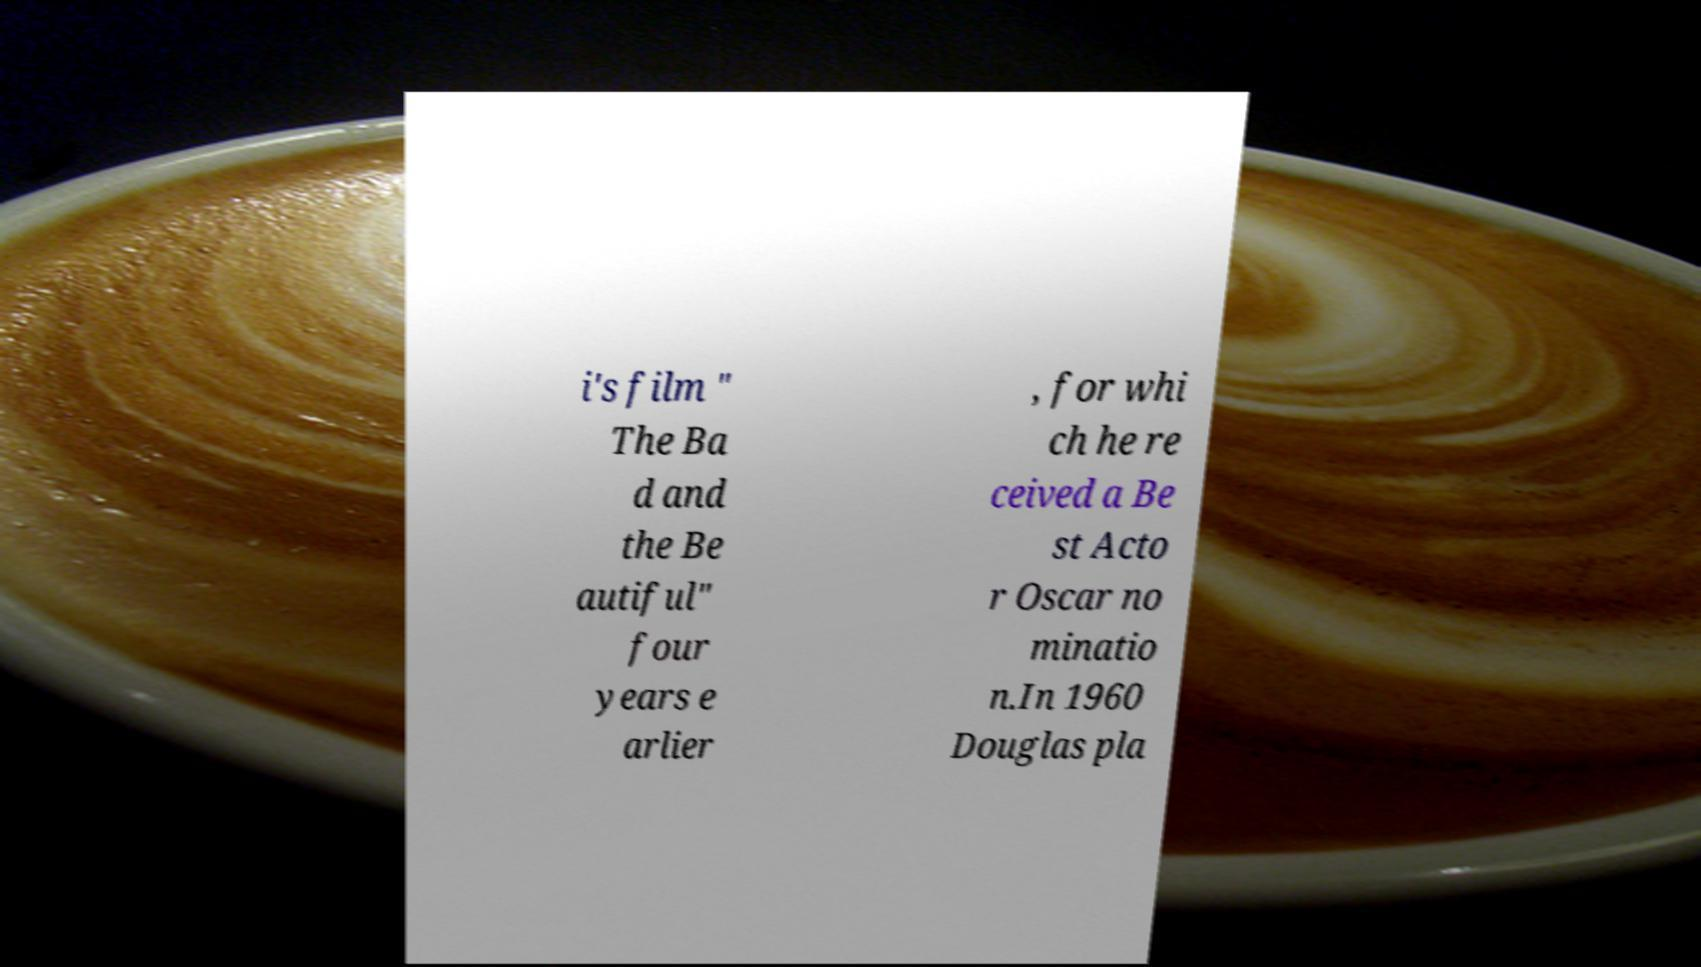There's text embedded in this image that I need extracted. Can you transcribe it verbatim? i's film " The Ba d and the Be autiful" four years e arlier , for whi ch he re ceived a Be st Acto r Oscar no minatio n.In 1960 Douglas pla 